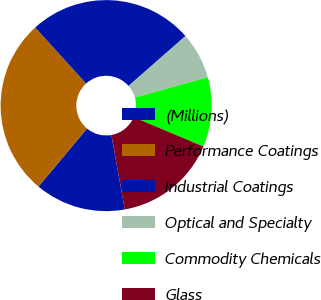Convert chart. <chart><loc_0><loc_0><loc_500><loc_500><pie_chart><fcel>(Millions)<fcel>Performance Coatings<fcel>Industrial Coatings<fcel>Optical and Specialty<fcel>Commodity Chemicals<fcel>Glass<nl><fcel>13.91%<fcel>27.19%<fcel>25.27%<fcel>7.13%<fcel>10.66%<fcel>15.84%<nl></chart> 